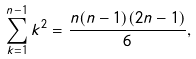<formula> <loc_0><loc_0><loc_500><loc_500>\sum _ { k = 1 } ^ { n - 1 } k ^ { 2 } = \frac { n ( n - 1 ) ( 2 n - 1 ) } { 6 } ,</formula> 